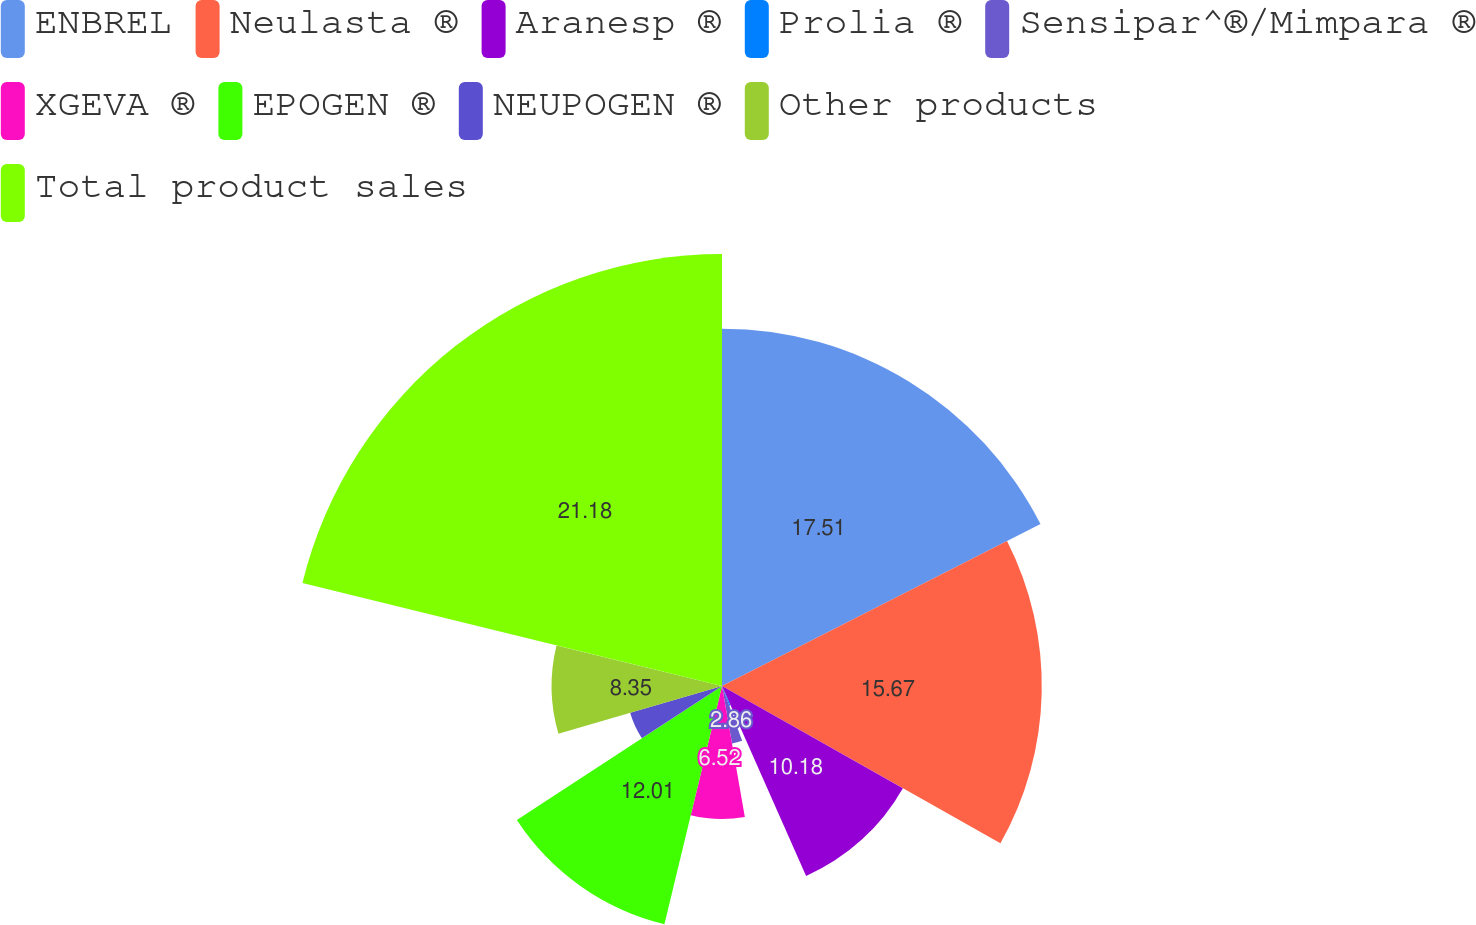<chart> <loc_0><loc_0><loc_500><loc_500><pie_chart><fcel>ENBREL<fcel>Neulasta ®<fcel>Aranesp ®<fcel>Prolia ®<fcel>Sensipar^®/Mimpara ®<fcel>XGEVA ®<fcel>EPOGEN ®<fcel>NEUPOGEN ®<fcel>Other products<fcel>Total product sales<nl><fcel>17.51%<fcel>15.67%<fcel>10.18%<fcel>1.03%<fcel>2.86%<fcel>6.52%<fcel>12.01%<fcel>4.69%<fcel>8.35%<fcel>21.17%<nl></chart> 